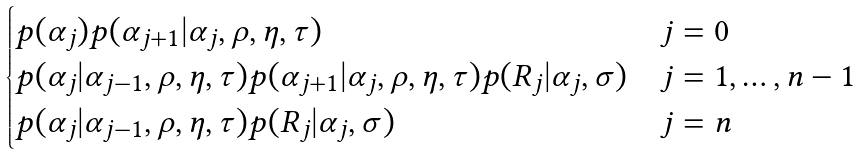Convert formula to latex. <formula><loc_0><loc_0><loc_500><loc_500>\begin{cases} p ( \alpha _ { j } ) p ( \alpha _ { j + 1 } | \alpha _ { j } , \rho , \eta , \tau ) & j = 0 \\ p ( \alpha _ { j } | \alpha _ { j - 1 } , \rho , \eta , \tau ) p ( \alpha _ { j + 1 } | \alpha _ { j } , \rho , \eta , \tau ) p ( R _ { j } | \alpha _ { j } , \sigma ) & j = 1 , \dots , n - 1 \\ p ( \alpha _ { j } | \alpha _ { j - 1 } , \rho , \eta , \tau ) p ( R _ { j } | \alpha _ { j } , \sigma ) & j = n \end{cases}</formula> 